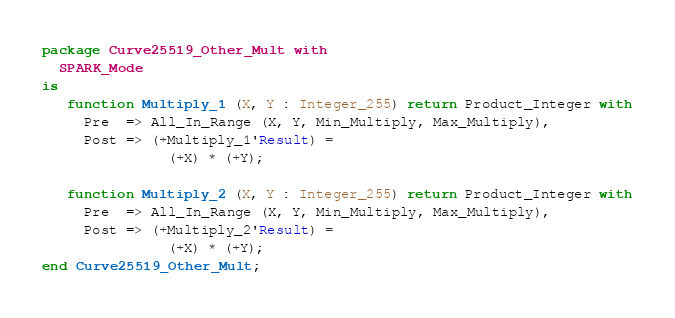<code> <loc_0><loc_0><loc_500><loc_500><_Ada_>package Curve25519_Other_Mult with
  SPARK_Mode
is
   function Multiply_1 (X, Y : Integer_255) return Product_Integer with
     Pre  => All_In_Range (X, Y, Min_Multiply, Max_Multiply),
     Post => (+Multiply_1'Result) =
               (+X) * (+Y);

   function Multiply_2 (X, Y : Integer_255) return Product_Integer with
     Pre  => All_In_Range (X, Y, Min_Multiply, Max_Multiply),
     Post => (+Multiply_2'Result) =
               (+X) * (+Y);
end Curve25519_Other_Mult;
</code> 